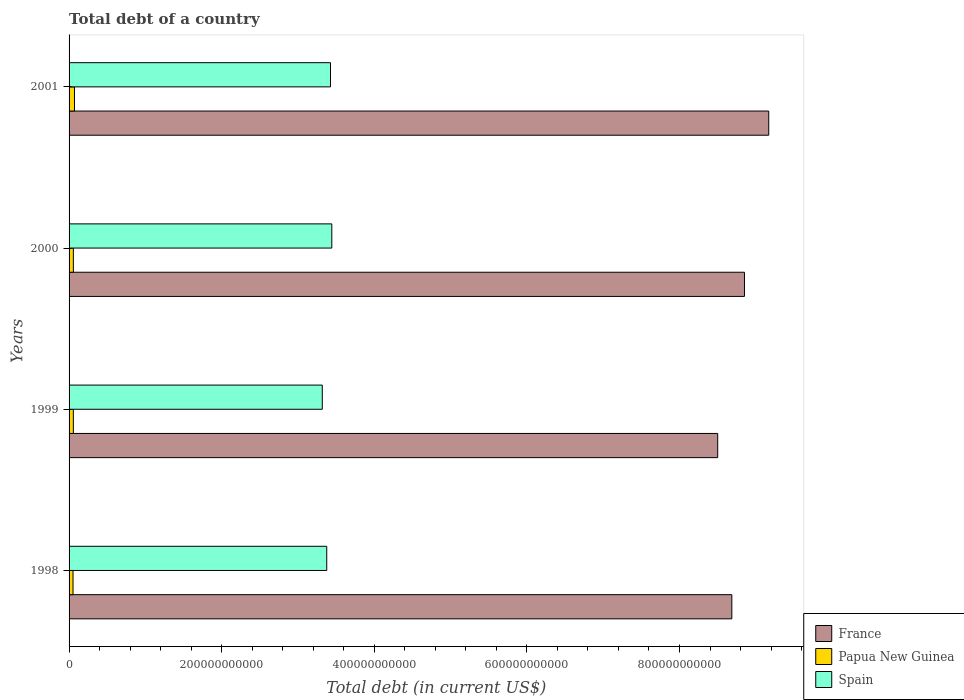How many groups of bars are there?
Ensure brevity in your answer.  4. Are the number of bars on each tick of the Y-axis equal?
Offer a very short reply. Yes. What is the label of the 4th group of bars from the top?
Make the answer very short. 1998. What is the debt in Papua New Guinea in 1999?
Your answer should be very brief. 5.61e+09. Across all years, what is the maximum debt in Spain?
Offer a very short reply. 3.44e+11. Across all years, what is the minimum debt in Spain?
Offer a terse response. 3.32e+11. In which year was the debt in Spain maximum?
Your answer should be very brief. 2000. In which year was the debt in France minimum?
Ensure brevity in your answer.  1999. What is the total debt in Papua New Guinea in the graph?
Give a very brief answer. 2.35e+1. What is the difference between the debt in Papua New Guinea in 2000 and that in 2001?
Make the answer very short. -1.48e+09. What is the difference between the debt in France in 2000 and the debt in Papua New Guinea in 1998?
Offer a very short reply. 8.80e+11. What is the average debt in France per year?
Your response must be concise. 8.80e+11. In the year 1999, what is the difference between the debt in Papua New Guinea and debt in Spain?
Provide a succinct answer. -3.26e+11. What is the ratio of the debt in Papua New Guinea in 1999 to that in 2001?
Provide a short and direct response. 0.79. Is the debt in Papua New Guinea in 1999 less than that in 2000?
Offer a terse response. Yes. What is the difference between the highest and the second highest debt in Spain?
Keep it short and to the point. 1.70e+09. What is the difference between the highest and the lowest debt in France?
Your answer should be compact. 6.69e+1. What does the 2nd bar from the bottom in 1998 represents?
Offer a very short reply. Papua New Guinea. How many years are there in the graph?
Offer a very short reply. 4. What is the difference between two consecutive major ticks on the X-axis?
Provide a short and direct response. 2.00e+11. Are the values on the major ticks of X-axis written in scientific E-notation?
Give a very brief answer. No. Where does the legend appear in the graph?
Give a very brief answer. Bottom right. How many legend labels are there?
Ensure brevity in your answer.  3. How are the legend labels stacked?
Give a very brief answer. Vertical. What is the title of the graph?
Make the answer very short. Total debt of a country. Does "Burundi" appear as one of the legend labels in the graph?
Offer a very short reply. No. What is the label or title of the X-axis?
Provide a short and direct response. Total debt (in current US$). What is the Total debt (in current US$) of France in 1998?
Keep it short and to the point. 8.69e+11. What is the Total debt (in current US$) of Papua New Guinea in 1998?
Provide a short and direct response. 5.18e+09. What is the Total debt (in current US$) in Spain in 1998?
Provide a short and direct response. 3.38e+11. What is the Total debt (in current US$) in France in 1999?
Offer a terse response. 8.50e+11. What is the Total debt (in current US$) of Papua New Guinea in 1999?
Offer a very short reply. 5.61e+09. What is the Total debt (in current US$) in Spain in 1999?
Make the answer very short. 3.32e+11. What is the Total debt (in current US$) in France in 2000?
Your answer should be compact. 8.85e+11. What is the Total debt (in current US$) of Papua New Guinea in 2000?
Your answer should be very brief. 5.62e+09. What is the Total debt (in current US$) of Spain in 2000?
Keep it short and to the point. 3.44e+11. What is the Total debt (in current US$) of France in 2001?
Make the answer very short. 9.17e+11. What is the Total debt (in current US$) in Papua New Guinea in 2001?
Give a very brief answer. 7.10e+09. What is the Total debt (in current US$) of Spain in 2001?
Make the answer very short. 3.43e+11. Across all years, what is the maximum Total debt (in current US$) in France?
Ensure brevity in your answer.  9.17e+11. Across all years, what is the maximum Total debt (in current US$) of Papua New Guinea?
Ensure brevity in your answer.  7.10e+09. Across all years, what is the maximum Total debt (in current US$) of Spain?
Offer a very short reply. 3.44e+11. Across all years, what is the minimum Total debt (in current US$) in France?
Make the answer very short. 8.50e+11. Across all years, what is the minimum Total debt (in current US$) in Papua New Guinea?
Provide a succinct answer. 5.18e+09. Across all years, what is the minimum Total debt (in current US$) in Spain?
Offer a very short reply. 3.32e+11. What is the total Total debt (in current US$) of France in the graph?
Provide a succinct answer. 3.52e+12. What is the total Total debt (in current US$) of Papua New Guinea in the graph?
Give a very brief answer. 2.35e+1. What is the total Total debt (in current US$) of Spain in the graph?
Make the answer very short. 1.36e+12. What is the difference between the Total debt (in current US$) in France in 1998 and that in 1999?
Your answer should be compact. 1.85e+1. What is the difference between the Total debt (in current US$) of Papua New Guinea in 1998 and that in 1999?
Your answer should be compact. -4.32e+08. What is the difference between the Total debt (in current US$) in Spain in 1998 and that in 1999?
Provide a succinct answer. 5.84e+09. What is the difference between the Total debt (in current US$) of France in 1998 and that in 2000?
Make the answer very short. -1.66e+1. What is the difference between the Total debt (in current US$) in Papua New Guinea in 1998 and that in 2000?
Offer a terse response. -4.44e+08. What is the difference between the Total debt (in current US$) in Spain in 1998 and that in 2000?
Offer a very short reply. -6.62e+09. What is the difference between the Total debt (in current US$) of France in 1998 and that in 2001?
Your response must be concise. -4.84e+1. What is the difference between the Total debt (in current US$) of Papua New Guinea in 1998 and that in 2001?
Make the answer very short. -1.92e+09. What is the difference between the Total debt (in current US$) in Spain in 1998 and that in 2001?
Offer a very short reply. -4.92e+09. What is the difference between the Total debt (in current US$) in France in 1999 and that in 2000?
Offer a very short reply. -3.51e+1. What is the difference between the Total debt (in current US$) of Papua New Guinea in 1999 and that in 2000?
Make the answer very short. -1.24e+07. What is the difference between the Total debt (in current US$) of Spain in 1999 and that in 2000?
Your response must be concise. -1.25e+1. What is the difference between the Total debt (in current US$) in France in 1999 and that in 2001?
Offer a terse response. -6.69e+1. What is the difference between the Total debt (in current US$) in Papua New Guinea in 1999 and that in 2001?
Your response must be concise. -1.49e+09. What is the difference between the Total debt (in current US$) of Spain in 1999 and that in 2001?
Offer a very short reply. -1.08e+1. What is the difference between the Total debt (in current US$) of France in 2000 and that in 2001?
Make the answer very short. -3.18e+1. What is the difference between the Total debt (in current US$) of Papua New Guinea in 2000 and that in 2001?
Offer a terse response. -1.48e+09. What is the difference between the Total debt (in current US$) in Spain in 2000 and that in 2001?
Keep it short and to the point. 1.70e+09. What is the difference between the Total debt (in current US$) of France in 1998 and the Total debt (in current US$) of Papua New Guinea in 1999?
Ensure brevity in your answer.  8.63e+11. What is the difference between the Total debt (in current US$) of France in 1998 and the Total debt (in current US$) of Spain in 1999?
Ensure brevity in your answer.  5.37e+11. What is the difference between the Total debt (in current US$) of Papua New Guinea in 1998 and the Total debt (in current US$) of Spain in 1999?
Ensure brevity in your answer.  -3.27e+11. What is the difference between the Total debt (in current US$) in France in 1998 and the Total debt (in current US$) in Papua New Guinea in 2000?
Keep it short and to the point. 8.63e+11. What is the difference between the Total debt (in current US$) in France in 1998 and the Total debt (in current US$) in Spain in 2000?
Your answer should be compact. 5.24e+11. What is the difference between the Total debt (in current US$) of Papua New Guinea in 1998 and the Total debt (in current US$) of Spain in 2000?
Make the answer very short. -3.39e+11. What is the difference between the Total debt (in current US$) of France in 1998 and the Total debt (in current US$) of Papua New Guinea in 2001?
Offer a terse response. 8.62e+11. What is the difference between the Total debt (in current US$) of France in 1998 and the Total debt (in current US$) of Spain in 2001?
Ensure brevity in your answer.  5.26e+11. What is the difference between the Total debt (in current US$) in Papua New Guinea in 1998 and the Total debt (in current US$) in Spain in 2001?
Your response must be concise. -3.37e+11. What is the difference between the Total debt (in current US$) of France in 1999 and the Total debt (in current US$) of Papua New Guinea in 2000?
Your response must be concise. 8.44e+11. What is the difference between the Total debt (in current US$) in France in 1999 and the Total debt (in current US$) in Spain in 2000?
Keep it short and to the point. 5.06e+11. What is the difference between the Total debt (in current US$) of Papua New Guinea in 1999 and the Total debt (in current US$) of Spain in 2000?
Your answer should be compact. -3.39e+11. What is the difference between the Total debt (in current US$) of France in 1999 and the Total debt (in current US$) of Papua New Guinea in 2001?
Your answer should be very brief. 8.43e+11. What is the difference between the Total debt (in current US$) of France in 1999 and the Total debt (in current US$) of Spain in 2001?
Keep it short and to the point. 5.07e+11. What is the difference between the Total debt (in current US$) of Papua New Guinea in 1999 and the Total debt (in current US$) of Spain in 2001?
Keep it short and to the point. -3.37e+11. What is the difference between the Total debt (in current US$) of France in 2000 and the Total debt (in current US$) of Papua New Guinea in 2001?
Offer a terse response. 8.78e+11. What is the difference between the Total debt (in current US$) in France in 2000 and the Total debt (in current US$) in Spain in 2001?
Make the answer very short. 5.43e+11. What is the difference between the Total debt (in current US$) in Papua New Guinea in 2000 and the Total debt (in current US$) in Spain in 2001?
Your answer should be compact. -3.37e+11. What is the average Total debt (in current US$) in France per year?
Give a very brief answer. 8.80e+11. What is the average Total debt (in current US$) of Papua New Guinea per year?
Offer a very short reply. 5.88e+09. What is the average Total debt (in current US$) in Spain per year?
Your response must be concise. 3.39e+11. In the year 1998, what is the difference between the Total debt (in current US$) in France and Total debt (in current US$) in Papua New Guinea?
Make the answer very short. 8.63e+11. In the year 1998, what is the difference between the Total debt (in current US$) in France and Total debt (in current US$) in Spain?
Ensure brevity in your answer.  5.31e+11. In the year 1998, what is the difference between the Total debt (in current US$) in Papua New Guinea and Total debt (in current US$) in Spain?
Offer a terse response. -3.33e+11. In the year 1999, what is the difference between the Total debt (in current US$) in France and Total debt (in current US$) in Papua New Guinea?
Your answer should be compact. 8.44e+11. In the year 1999, what is the difference between the Total debt (in current US$) in France and Total debt (in current US$) in Spain?
Keep it short and to the point. 5.18e+11. In the year 1999, what is the difference between the Total debt (in current US$) in Papua New Guinea and Total debt (in current US$) in Spain?
Keep it short and to the point. -3.26e+11. In the year 2000, what is the difference between the Total debt (in current US$) of France and Total debt (in current US$) of Papua New Guinea?
Your response must be concise. 8.80e+11. In the year 2000, what is the difference between the Total debt (in current US$) in France and Total debt (in current US$) in Spain?
Keep it short and to the point. 5.41e+11. In the year 2000, what is the difference between the Total debt (in current US$) of Papua New Guinea and Total debt (in current US$) of Spain?
Give a very brief answer. -3.39e+11. In the year 2001, what is the difference between the Total debt (in current US$) in France and Total debt (in current US$) in Papua New Guinea?
Provide a succinct answer. 9.10e+11. In the year 2001, what is the difference between the Total debt (in current US$) in France and Total debt (in current US$) in Spain?
Provide a succinct answer. 5.74e+11. In the year 2001, what is the difference between the Total debt (in current US$) of Papua New Guinea and Total debt (in current US$) of Spain?
Ensure brevity in your answer.  -3.36e+11. What is the ratio of the Total debt (in current US$) of France in 1998 to that in 1999?
Offer a very short reply. 1.02. What is the ratio of the Total debt (in current US$) in Papua New Guinea in 1998 to that in 1999?
Your answer should be compact. 0.92. What is the ratio of the Total debt (in current US$) of Spain in 1998 to that in 1999?
Your answer should be very brief. 1.02. What is the ratio of the Total debt (in current US$) in France in 1998 to that in 2000?
Provide a short and direct response. 0.98. What is the ratio of the Total debt (in current US$) in Papua New Guinea in 1998 to that in 2000?
Offer a terse response. 0.92. What is the ratio of the Total debt (in current US$) of Spain in 1998 to that in 2000?
Offer a very short reply. 0.98. What is the ratio of the Total debt (in current US$) in France in 1998 to that in 2001?
Give a very brief answer. 0.95. What is the ratio of the Total debt (in current US$) of Papua New Guinea in 1998 to that in 2001?
Keep it short and to the point. 0.73. What is the ratio of the Total debt (in current US$) of Spain in 1998 to that in 2001?
Provide a succinct answer. 0.99. What is the ratio of the Total debt (in current US$) of France in 1999 to that in 2000?
Provide a short and direct response. 0.96. What is the ratio of the Total debt (in current US$) of Papua New Guinea in 1999 to that in 2000?
Make the answer very short. 1. What is the ratio of the Total debt (in current US$) of Spain in 1999 to that in 2000?
Give a very brief answer. 0.96. What is the ratio of the Total debt (in current US$) of France in 1999 to that in 2001?
Ensure brevity in your answer.  0.93. What is the ratio of the Total debt (in current US$) of Papua New Guinea in 1999 to that in 2001?
Offer a very short reply. 0.79. What is the ratio of the Total debt (in current US$) of Spain in 1999 to that in 2001?
Keep it short and to the point. 0.97. What is the ratio of the Total debt (in current US$) of France in 2000 to that in 2001?
Make the answer very short. 0.97. What is the ratio of the Total debt (in current US$) of Papua New Guinea in 2000 to that in 2001?
Your answer should be very brief. 0.79. What is the ratio of the Total debt (in current US$) of Spain in 2000 to that in 2001?
Make the answer very short. 1. What is the difference between the highest and the second highest Total debt (in current US$) in France?
Ensure brevity in your answer.  3.18e+1. What is the difference between the highest and the second highest Total debt (in current US$) in Papua New Guinea?
Ensure brevity in your answer.  1.48e+09. What is the difference between the highest and the second highest Total debt (in current US$) in Spain?
Give a very brief answer. 1.70e+09. What is the difference between the highest and the lowest Total debt (in current US$) of France?
Your response must be concise. 6.69e+1. What is the difference between the highest and the lowest Total debt (in current US$) in Papua New Guinea?
Provide a succinct answer. 1.92e+09. What is the difference between the highest and the lowest Total debt (in current US$) in Spain?
Your answer should be very brief. 1.25e+1. 